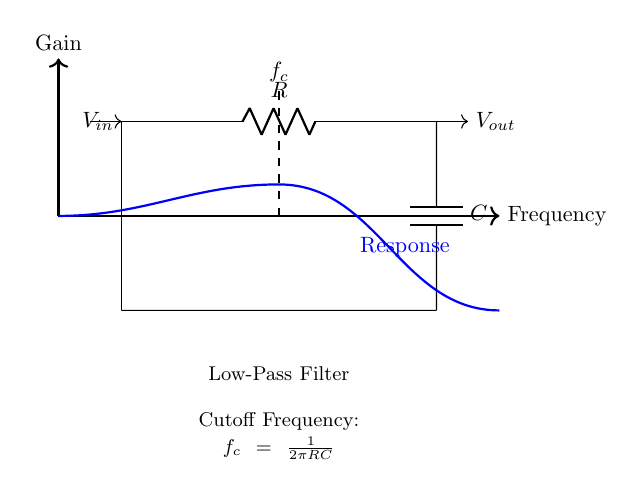What are the components in the circuit? The circuit diagram clearly shows a resistor represented by R and a capacitor represented by C. These components are instrumental in forming the low-pass filter.
Answer: Resistor and Capacitor What is the purpose of this filter? The low-pass filter is intended to allow signals with frequencies lower than its cutoff frequency to pass through while attenuating signals with frequencies higher than that threshold.
Answer: Reduce noise What is the cutoff frequency formula? The diagram includes a note stating the cutoff frequency is expressed as f_c = 1/2πRC. This formula highlights the relationship between the resistor, capacitor, and the frequency of the filter's response.
Answer: f_c = 1/2πRC How does this filter affect high frequency signals? In a low-pass filter setup, high frequency signals are significantly reduced or attenuated above the cutoff frequency, which makes it effective for noise reduction in radio communications.
Answer: Attenuates What type of filter is represented? The circuit diagram illustrates a low-pass filter, specifically designed to allow lower frequencies while blocking higher frequencies beyond the cutoff point.
Answer: Low-pass filter What happens to the output voltage at the cutoff frequency? At the cutoff frequency, the output voltage is reduced to about 70.7% of the input voltage, demonstrating the filter's effectiveness at that critical frequency.
Answer: 70.7% 